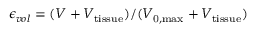Convert formula to latex. <formula><loc_0><loc_0><loc_500><loc_500>\epsilon _ { v o l } = ( V + V _ { t i s s u e } ) / ( V _ { 0 , \max } + V _ { t i s s u e } )</formula> 